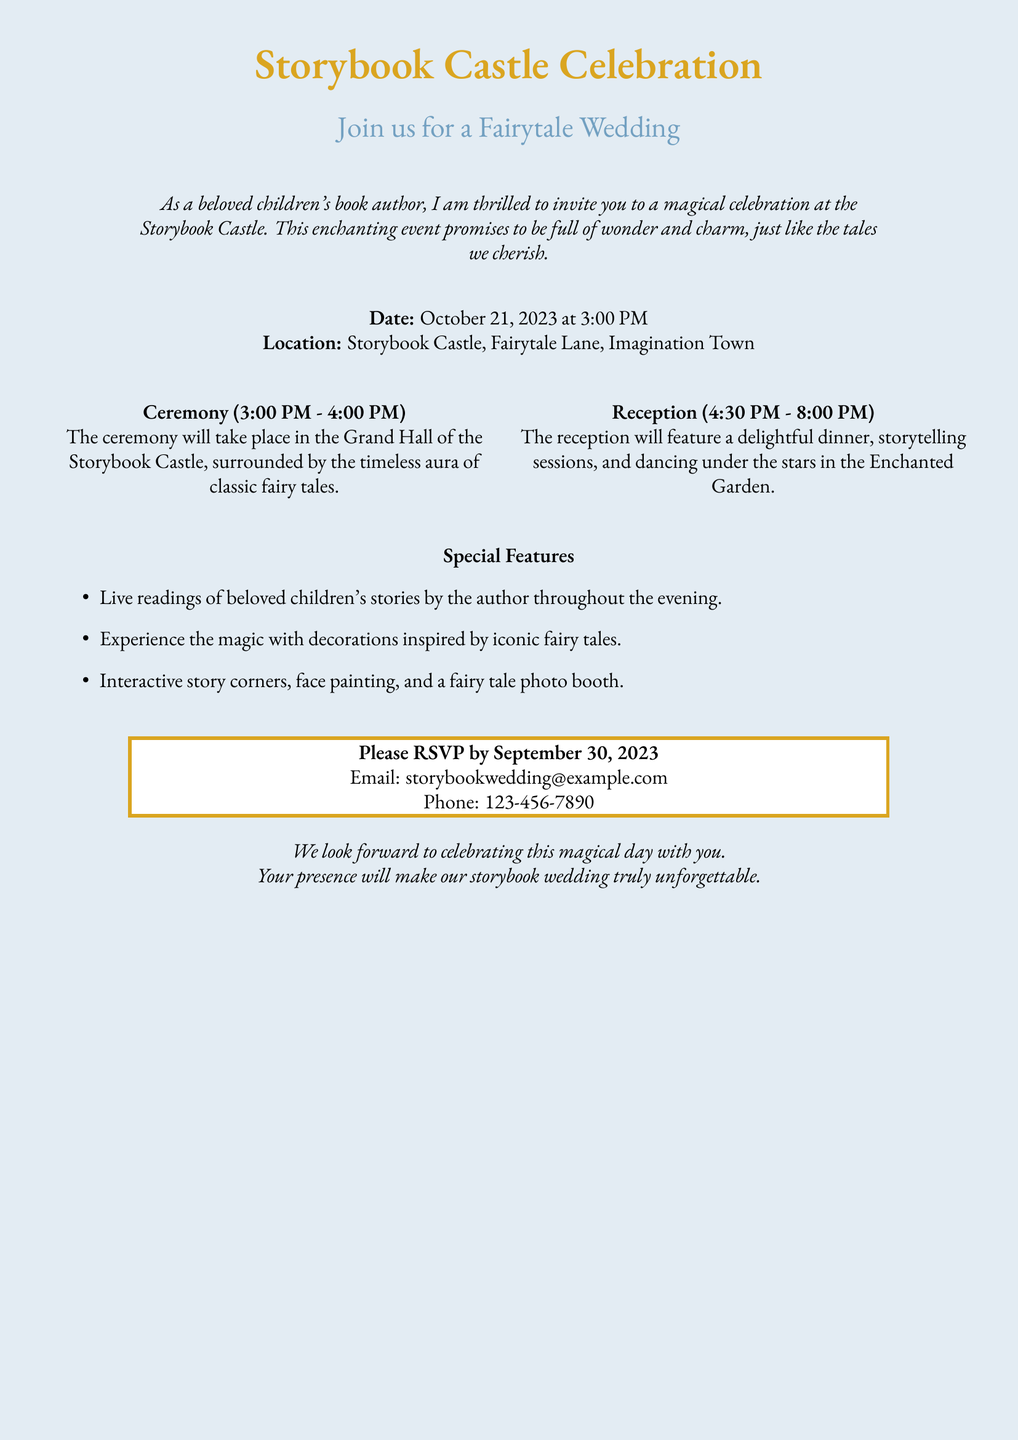What is the date of the wedding? The wedding is scheduled for October 21, 2023, as mentioned in the invitation.
Answer: October 21, 2023 What time does the ceremony start? The ceremony begins at 3:00 PM, as specified in the document.
Answer: 3:00 PM Where is the wedding located? The wedding takes place at Storybook Castle, Imagination Town, according to the invitation.
Answer: Storybook Castle, Imagination Town What type of dinner will be featured at the reception? The reception will feature "a delightful dinner," which indicates the nature of the meal, based on the document details.
Answer: Delightful dinner What is one special feature mentioned in the invitation? The document mentions live readings of beloved children's stories as one of the special features.
Answer: Live readings How long will the reception last? The reception is scheduled from 4:30 PM to 8:00 PM, giving the overall duration of the event.
Answer: 4:30 PM - 8:00 PM What is the RSVP deadline? The RSVP deadline is set for September 30, 2023, as noted in the invitation.
Answer: September 30, 2023 What is the email address for RSVPs? The email address provided for RSVPs is storybookwedding@example.com.
Answer: storybookwedding@example.com What will happen in the Enchanted Garden? The Enchanted Garden will host dancing under the stars, according to the invitation's reception details.
Answer: Dancing under the stars 